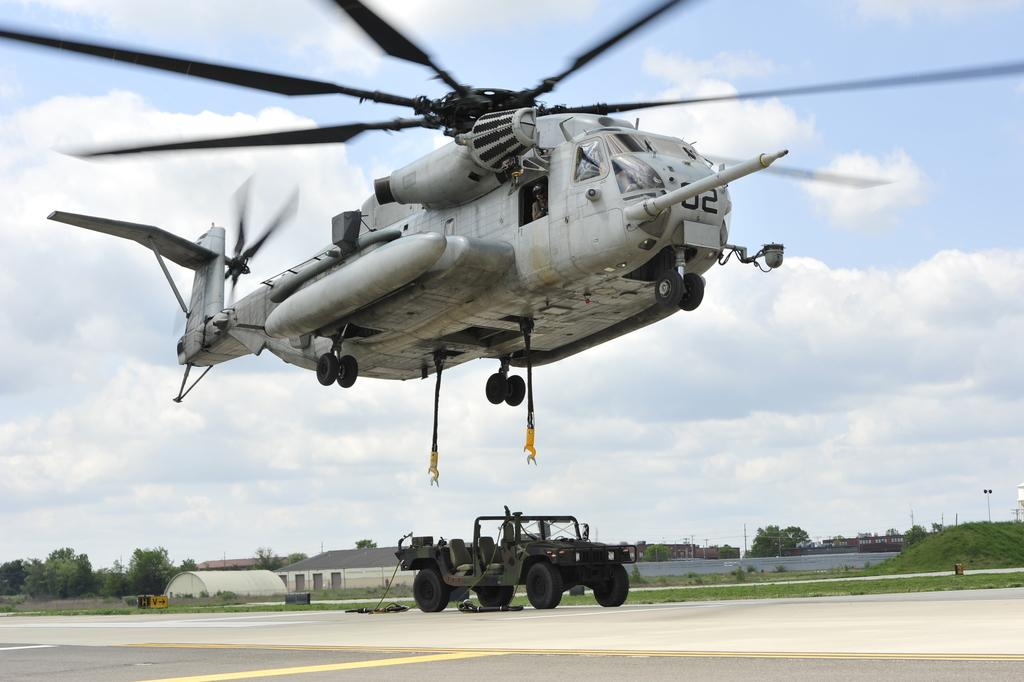What is the main subject of the image? The main subject of the image is an aircraft. Can you describe the color of the aircraft? The aircraft is white. What can be seen in the background of the image? There are vehicles on the road and buildings in the image. How are the buildings colored? The buildings are in cream color. What type of vegetation is present in the image? There are trees in the image, and they are green. What is visible in the sky in the image? The sky is visible in the image, and it is a combination of white and blue. What type of page can be seen in the image? There is no page present in the image; it features an aircraft, vehicles, buildings, trees, and the sky. Can you describe the teeth of the aircraft in the image? Aircraft do not have teeth, so this question is not applicable to the image. 